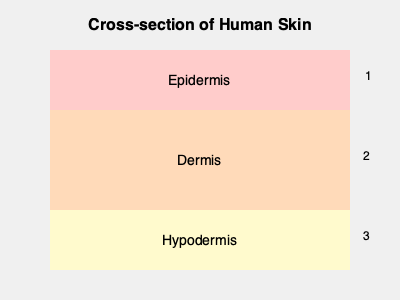In the cross-section diagram of human skin, which layer is primarily responsible for thermoregulation and energy storage? Provide the number corresponding to this layer. To answer this question, let's examine the three main layers of human skin and their functions:

1. Epidermis (Layer 1):
   - The outermost layer of the skin
   - Primary function: Barrier protection against environmental factors
   - Does not play a significant role in thermoregulation or energy storage

2. Dermis (Layer 2):
   - The middle layer of the skin
   - Contains blood vessels, nerve endings, and sweat glands
   - Plays a role in thermoregulation through blood flow and sweat production
   - Does not significantly contribute to energy storage

3. Hypodermis (Layer 3):
   - Also known as the subcutaneous layer
   - Composed primarily of adipose (fat) tissue
   - Main functions:
     a. Thermoregulation: Insulates the body to maintain core temperature
     b. Energy storage: Stores excess calories as fat for future use
   - This layer is crucial for both thermoregulation and energy storage

Based on this analysis, the layer primarily responsible for thermoregulation and energy storage is the hypodermis, which corresponds to number 3 in the diagram.
Answer: 3 